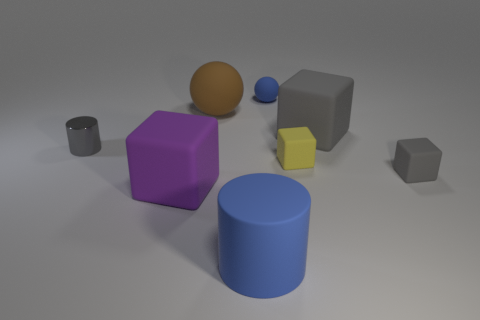Add 1 big purple metal spheres. How many objects exist? 9 Subtract all cylinders. How many objects are left? 6 Add 1 purple rubber cubes. How many purple rubber cubes exist? 2 Subtract 2 gray cubes. How many objects are left? 6 Subtract all big spheres. Subtract all small gray shiny things. How many objects are left? 6 Add 1 large purple matte things. How many large purple matte things are left? 2 